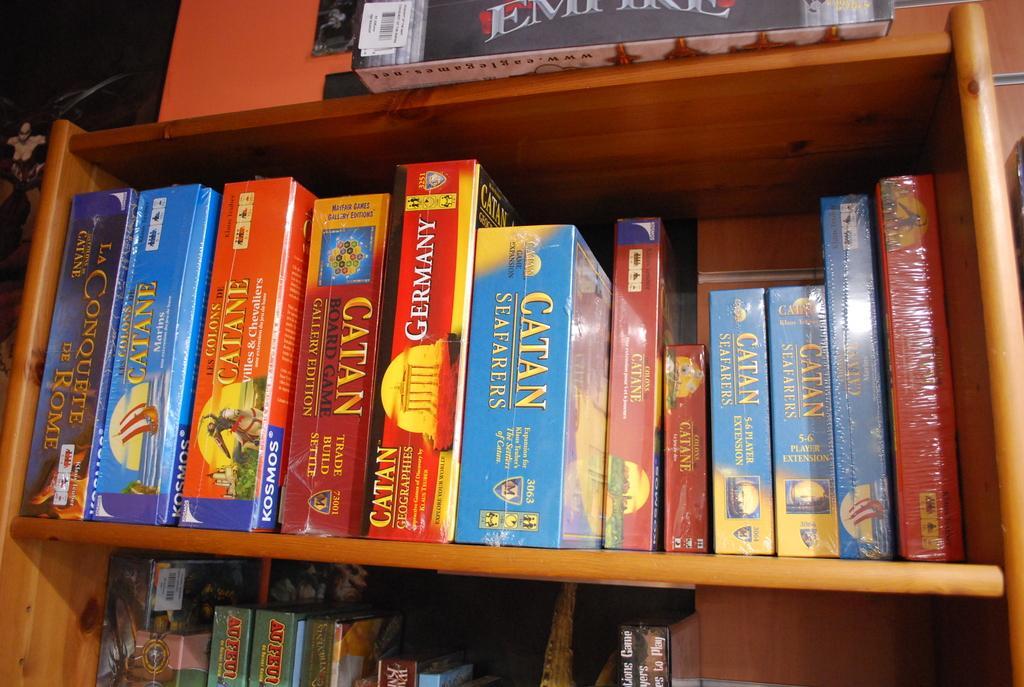Could you give a brief overview of what you see in this image? In this image I can see a book rack which is in brown color. I can see few books in it. 